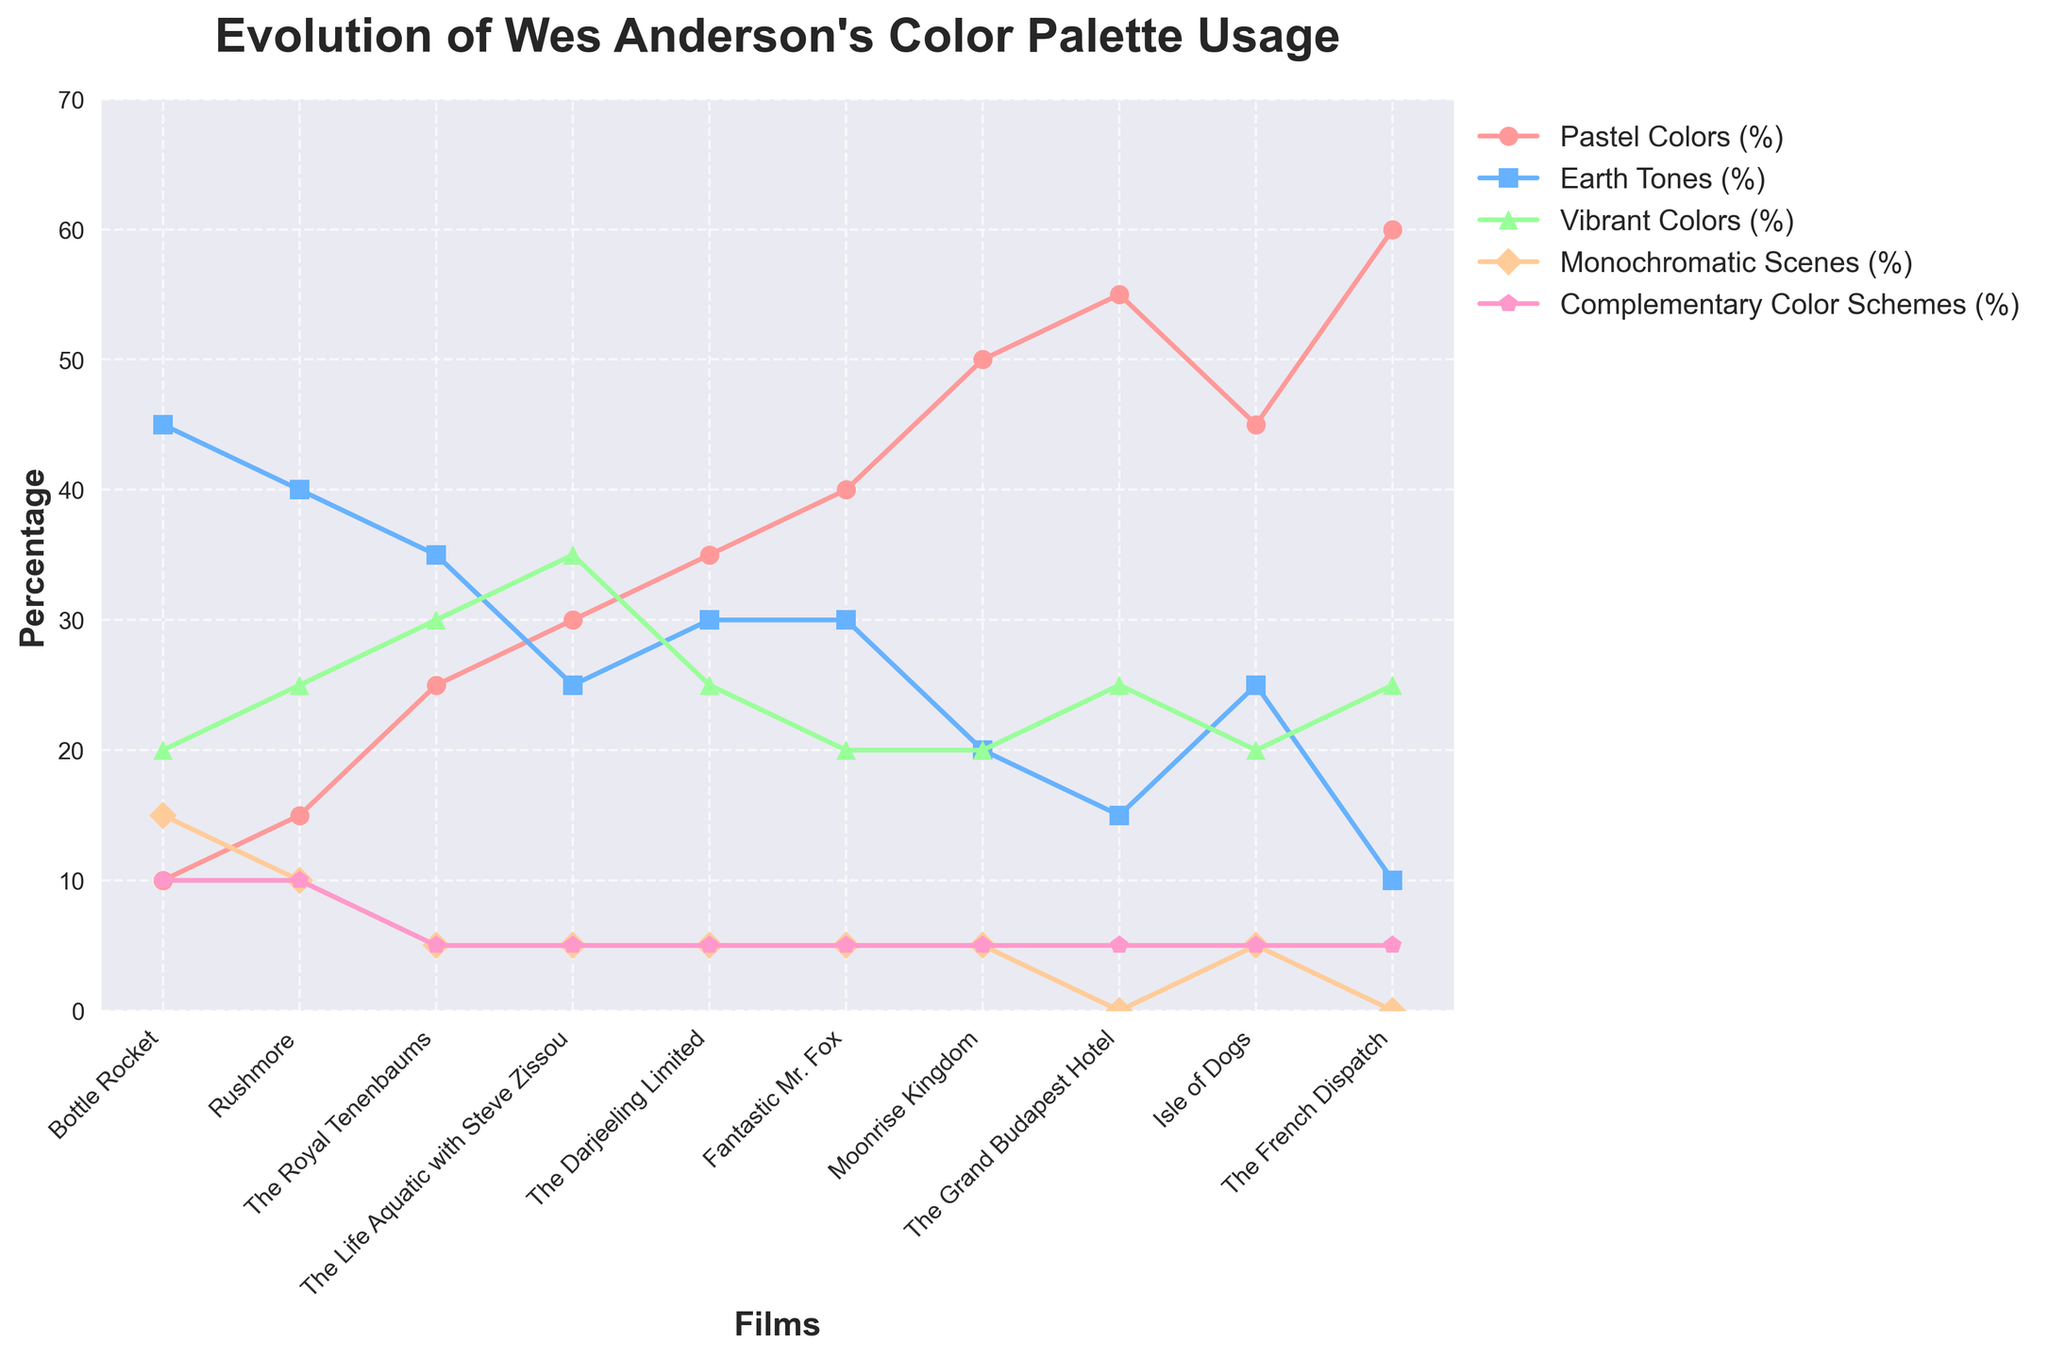What percentage of 'Monochromatic Scenes' is used in 'The Grand Budapest Hotel'? Check the data point for 'The Grand Budapest Hotel' corresponding to the 'Monochromatic Scenes' line, which is 0%.
Answer: 0% Which film has the highest percentage of 'Pastel Colors'? Observe the color-coded lines and find the peak for the 'Pastel Colors' line. 'The French Dispatch' has the highest percentage of 'Pastel Colors' at 60%.
Answer: The French Dispatch How does the use of 'Earth Tones' change from 'Bottle Rocket' to 'The French Dispatch'? Compare the 'Earth Tones' data points for 'Bottle Rocket' (45%) and 'The French Dispatch' (10%). The usage decreases by 35%.
Answer: Decreases by 35% Which film marks the highest increase in the usage of 'Vibrant Colors' compared to its predecessor? Examine the 'Vibrant Colors' data points. 'The Life Aquatic with Steve Zissou' (35%) had a 5% increase from 'The Royal Tenenbaums' (30%).
Answer: The Life Aquatic with Steve Zissou What is the average percentage of 'Complementary Color Schemes' across all films? Sum all the 'Complementary Color Schemes' percentages and divide by the number of films. (10 + 10 + 5 + 5 + 5 + 5 + 5 + 5 + 5 + 5) / 10 = 6%.
Answer: 6% Which two films have equal usage of 'Monochromatic Scenes'? Identify films with identical 'Monochromatic Scenes' percentages: 'The Royal Tenenbaums', 'The Life Aquatic with Steve Zissou', 'The Darjeeling Limited', 'Fantastic Mr. Fox', 'Moonrise Kingdom', and 'Isle of Dogs' each have 5%. 'The Grand Budapest Hotel' and 'The French Dispatch' have 0%.
Answer: The Royal Tenenbaums and The Life Aquatic with Steve Zissou By how much did the usage of 'Pastel Colors' increase from 'Rushmore' to 'Moonrise Kingdom'? Check the percentage values for 'Pastel Colors' in 'Rushmore' (15%) and 'Moonrise Kingdom' (50%), then calculate the difference, which is 50% - 15% = 35%.
Answer: 35% Which category of colors shows the most consistent (minimal change) usage across the films? Identify the category with the least variation in percentage values by visually inspecting the plotted lines. 'Complementary Color Schemes' remain constant around 5-10% for most films.
Answer: Complementary Color Schemes Between 'The Darjeeling Limited' and 'Isle of Dogs', which film has a higher percentage of 'Earth Tones'? Compare the 'Earth Tones' percentages from 'The Darjeeling Limited' (30%) and 'Isle of Dogs' (25%).
Answer: The Darjeeling Limited 